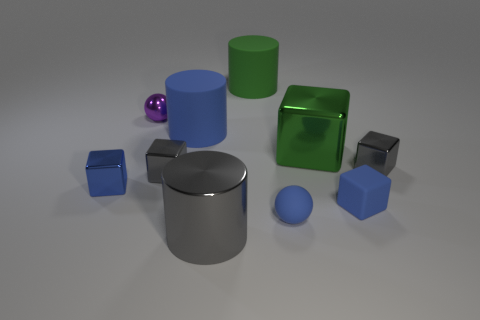Can you tell me which objects in the image are matte and which ones are glossy? Certainly. In the image, the small purple ball, the green cube, and the two smaller blue cubes exhibit matte finishes as they do not reflect light or surrounding objects. The large gray cylindrical object, the blue cylinder, the large shiny blue cube, and the ball behind the small matte ball have glossy surfaces, indicated by the reflections and highlights on them. 